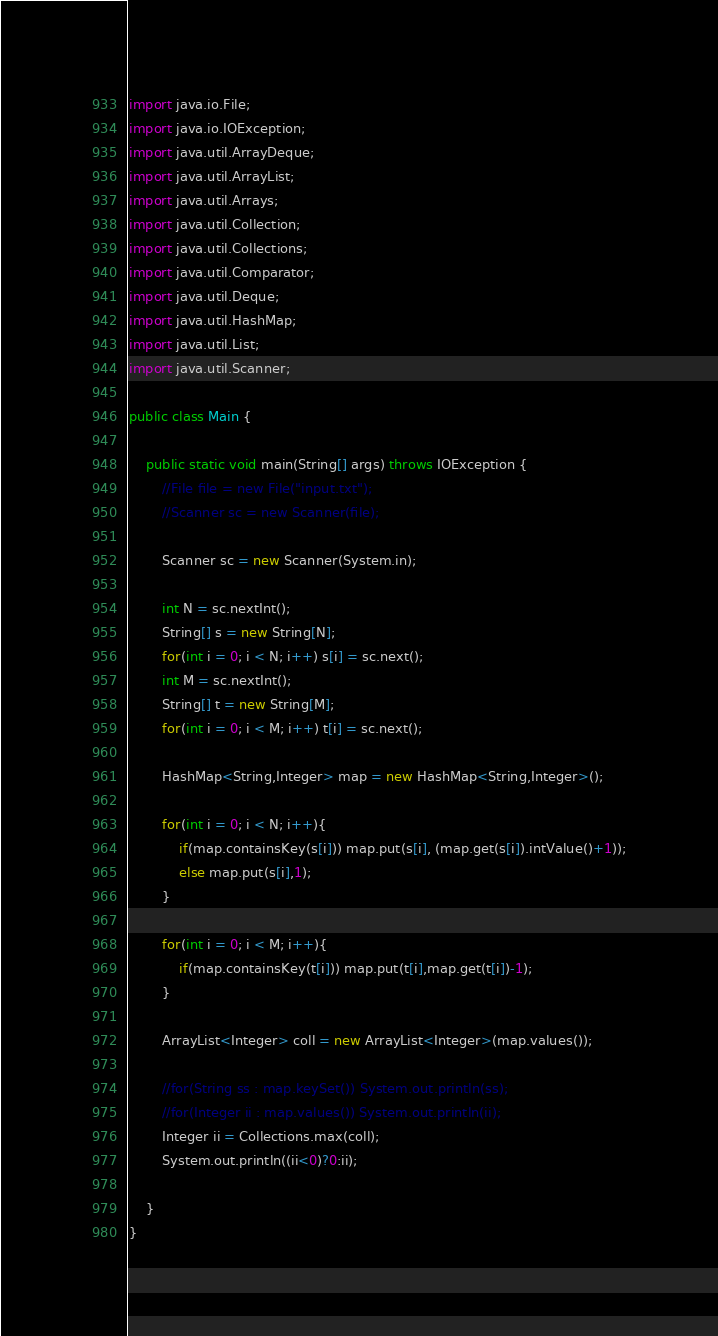<code> <loc_0><loc_0><loc_500><loc_500><_Java_>import java.io.File;
import java.io.IOException;
import java.util.ArrayDeque;
import java.util.ArrayList;
import java.util.Arrays;
import java.util.Collection;
import java.util.Collections;
import java.util.Comparator;
import java.util.Deque;
import java.util.HashMap;
import java.util.List;
import java.util.Scanner;

public class Main {
 
	public static void main(String[] args) throws IOException {
		//File file = new File("input.txt");
		//Scanner sc = new Scanner(file);
		
		Scanner sc = new Scanner(System.in);
		
		int N = sc.nextInt();
		String[] s = new String[N];
		for(int i = 0; i < N; i++) s[i] = sc.next();
		int M = sc.nextInt();
		String[] t = new String[M];
		for(int i = 0; i < M; i++) t[i] = sc.next();
		
		HashMap<String,Integer> map = new HashMap<String,Integer>();
		
		for(int i = 0; i < N; i++){
			if(map.containsKey(s[i])) map.put(s[i], (map.get(s[i]).intValue()+1));
			else map.put(s[i],1);
		}		
		
		for(int i = 0; i < M; i++){
			if(map.containsKey(t[i])) map.put(t[i],map.get(t[i])-1);
		}
				
		ArrayList<Integer> coll = new ArrayList<Integer>(map.values());
		
		//for(String ss : map.keySet()) System.out.println(ss);
		//for(Integer ii : map.values()) System.out.println(ii);
		Integer ii = Collections.max(coll);
		System.out.println((ii<0)?0:ii);
		
	}
}</code> 